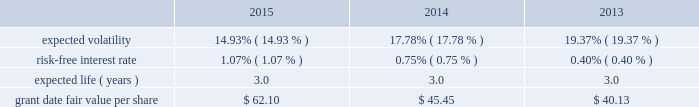During 2012 , the company granted selected employees an aggregate of 139 thousand rsus with internal performance measures and , separately , certain market thresholds .
These awards vested in january 2015 .
The terms of the grants specified that to the extent certain performance goals , comprised of internal measures and , separately , market thresholds were achieved , the rsus would vest ; if performance goals were surpassed , up to 175% ( 175 % ) of the target awards would be distributed ; and if performance goals were not met , the awards would be forfeited .
In january 2015 , an additional 93 thousand rsus were granted and distributed because performance thresholds were exceeded .
In 2015 , 2014 and 2013 , the company granted rsus , both with and without performance conditions , to certain employees under the 2007 plan .
The rsus without performance conditions vest ratably over the three- year service period beginning january 1 of the year of the grant and the rsus with performance conditions vest ratably over the three-year performance period beginning january 1 of the year of the grant ( the 201cperformance period 201d ) .
Distribution of the performance shares is contingent upon the achievement of internal performance measures and , separately , certain market thresholds over the performance period .
During 2015 , 2014 and 2013 , the company granted rsus to non-employee directors under the 2007 plan .
The rsus vested on the date of grant ; however , distribution of the shares will be made within 30 days of the earlier of : ( i ) 15 months after grant date , subject to any deferral election by the director ; or ( ii ) the participant 2019s separation from service .
Because these rsus vested on the grant date , the total grant date fair value was recorded in operation and maintenance expense included in the expense table above on the grant date .
Rsus generally vest over periods ranging from one to three years .
Rsus granted with service-only conditions and those with internal performance measures are valued at the market value of the closing price of the company 2019s common stock on the date of grant .
Rsus granted with market conditions are valued using a monte carlo model .
Expected volatility is based on historical volatilities of traded common stock of the company and comparative companies using daily stock prices over the past three years .
The expected term is three years and the risk-free interest rate is based on the three-year u.s .
Treasury rate in effect as of the measurement date .
The table presents the weighted-average assumptions used in the monte carlo simulation and the weighted-average grant date fair values of rsus granted for the years ended december 31: .
The grant date fair value of restricted stock awards that vest ratably and have market and/or performance and service conditions are amortized through expense over the requisite service period using the graded-vesting method .
Rsus that have no performance conditions are amortized through expense over the requisite service period using the straight-line method and are included in operations expense in the accompanying consolidated statements of operations .
As of december 31 , 2015 , $ 4 of total unrecognized compensation cost related to the nonvested restricted stock units is expected to be recognized over the weighted-average remaining life of 1.4 years .
The total grant date fair value of rsus vested was $ 12 , $ 11 and $ 9 for the years ended december 31 , 2015 , 2014 and 2013. .
By what percentage did grant date fair value per share increase from 2014 to 2015? 
Computations: ((62.10 - 45.45) / 45.45)
Answer: 0.36634. 